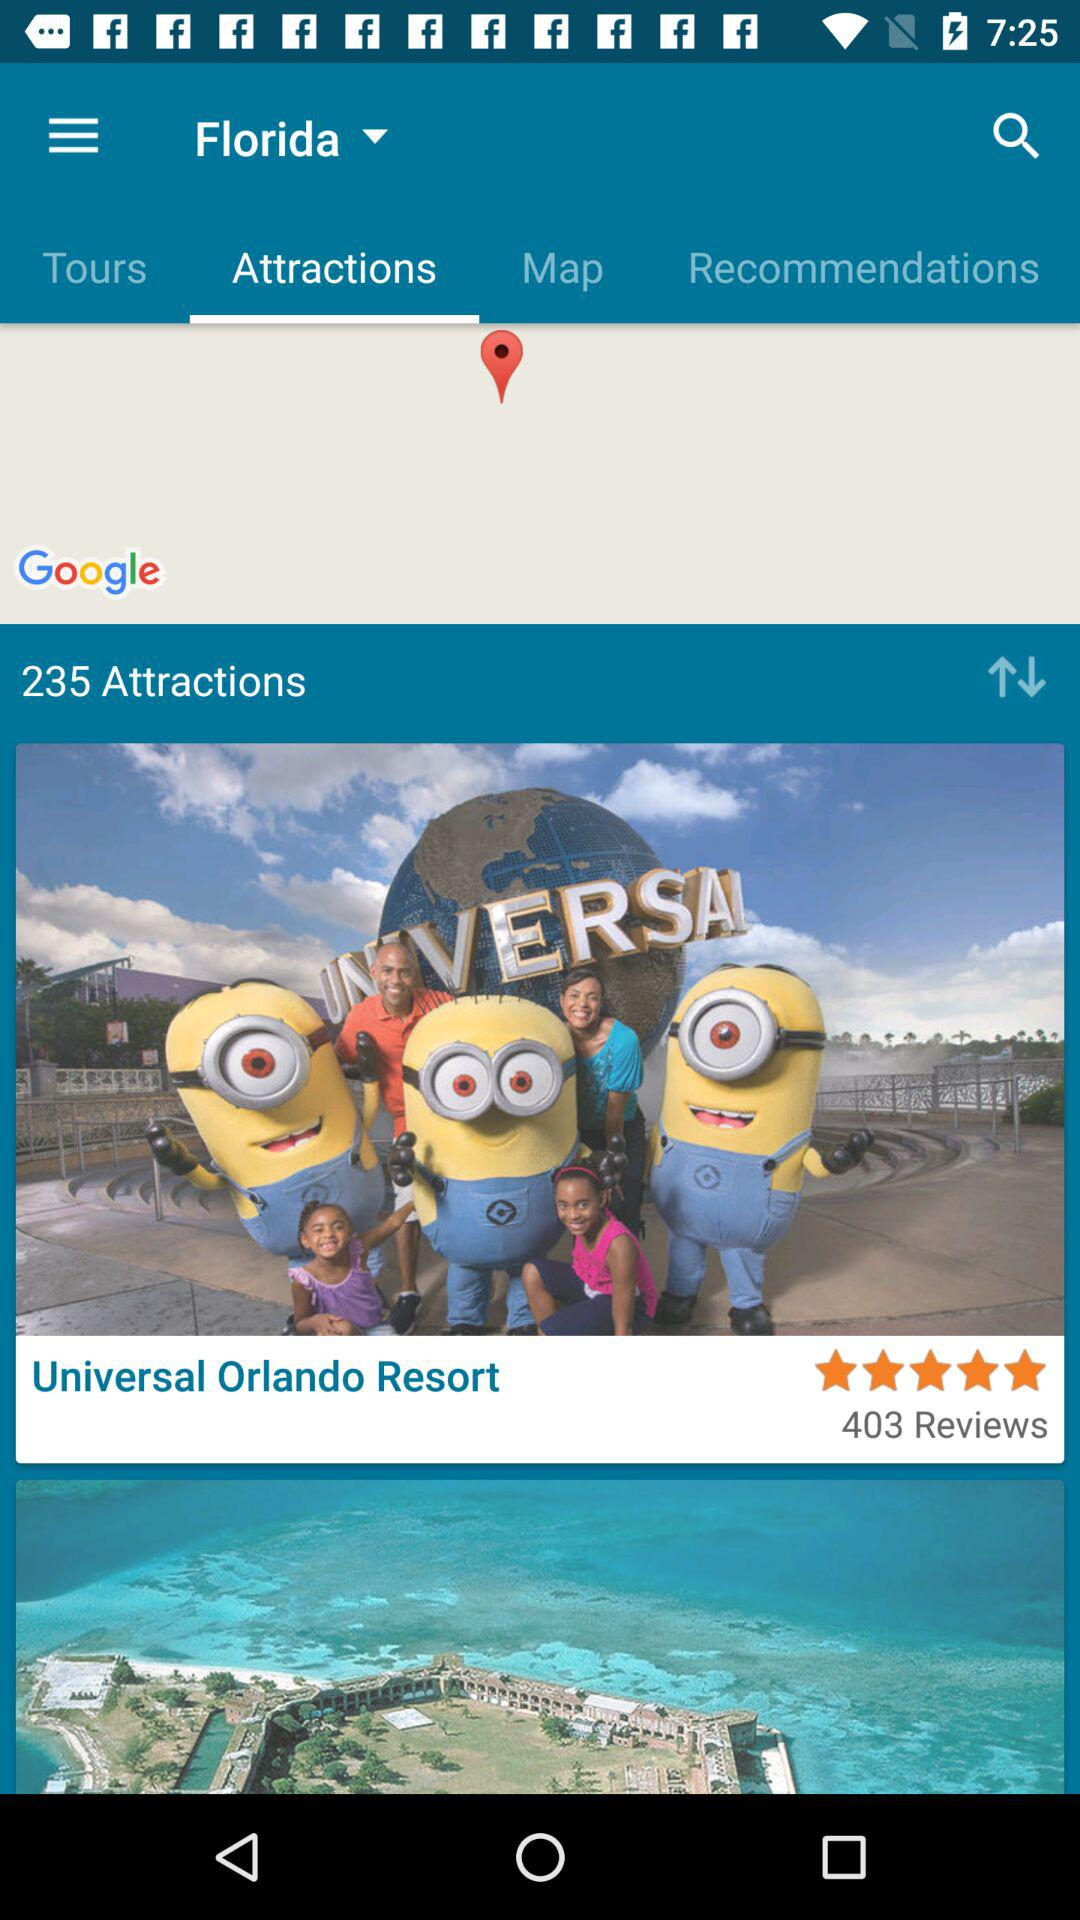How many attractions are there in total?
Answer the question using a single word or phrase. 235 